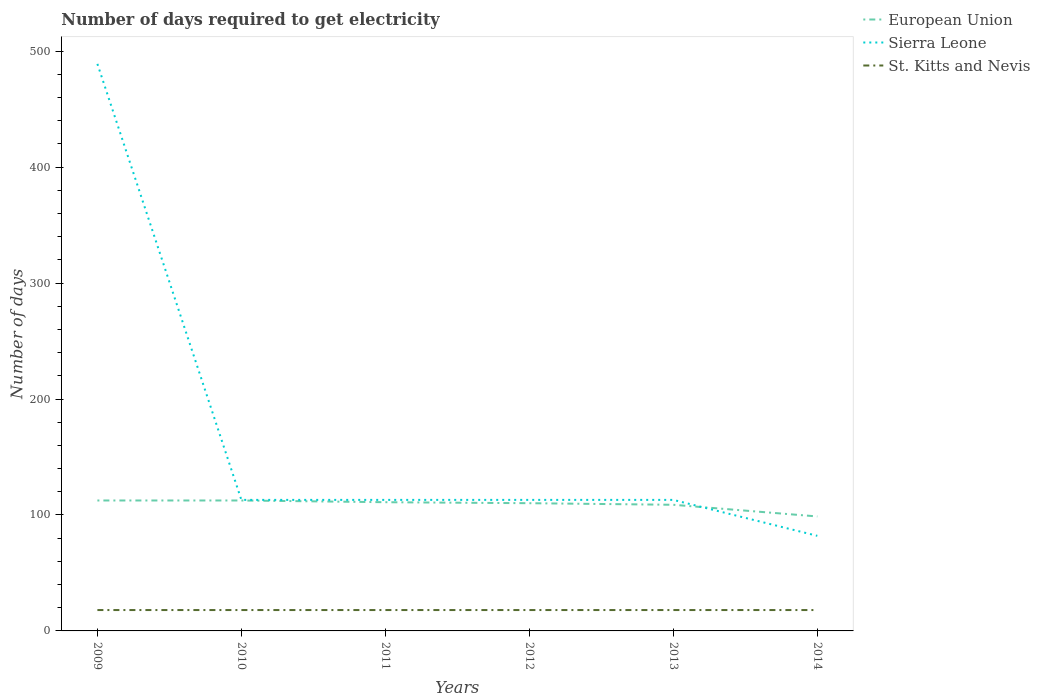How many different coloured lines are there?
Your answer should be compact. 3. Does the line corresponding to Sierra Leone intersect with the line corresponding to European Union?
Your answer should be very brief. Yes. Across all years, what is the maximum number of days required to get electricity in in Sierra Leone?
Your response must be concise. 82. In which year was the number of days required to get electricity in in Sierra Leone maximum?
Give a very brief answer. 2014. What is the total number of days required to get electricity in in St. Kitts and Nevis in the graph?
Your answer should be very brief. 0. What is the difference between the highest and the lowest number of days required to get electricity in in St. Kitts and Nevis?
Offer a terse response. 0. Is the number of days required to get electricity in in European Union strictly greater than the number of days required to get electricity in in Sierra Leone over the years?
Your answer should be compact. No. How many lines are there?
Provide a short and direct response. 3. What is the difference between two consecutive major ticks on the Y-axis?
Offer a terse response. 100. Are the values on the major ticks of Y-axis written in scientific E-notation?
Provide a short and direct response. No. Does the graph contain grids?
Offer a terse response. No. Where does the legend appear in the graph?
Offer a terse response. Top right. What is the title of the graph?
Offer a very short reply. Number of days required to get electricity. What is the label or title of the X-axis?
Your answer should be very brief. Years. What is the label or title of the Y-axis?
Provide a short and direct response. Number of days. What is the Number of days of European Union in 2009?
Ensure brevity in your answer.  112.48. What is the Number of days of Sierra Leone in 2009?
Provide a succinct answer. 489. What is the Number of days in European Union in 2010?
Provide a succinct answer. 112.48. What is the Number of days in Sierra Leone in 2010?
Make the answer very short. 113. What is the Number of days of European Union in 2011?
Provide a short and direct response. 111. What is the Number of days in Sierra Leone in 2011?
Your response must be concise. 113. What is the Number of days of St. Kitts and Nevis in 2011?
Give a very brief answer. 18. What is the Number of days in European Union in 2012?
Provide a short and direct response. 110.14. What is the Number of days of Sierra Leone in 2012?
Your answer should be compact. 113. What is the Number of days in St. Kitts and Nevis in 2012?
Your answer should be very brief. 18. What is the Number of days in European Union in 2013?
Ensure brevity in your answer.  108.79. What is the Number of days in Sierra Leone in 2013?
Provide a short and direct response. 113. What is the Number of days of St. Kitts and Nevis in 2013?
Offer a very short reply. 18. What is the Number of days in European Union in 2014?
Offer a very short reply. 98.71. What is the Number of days in St. Kitts and Nevis in 2014?
Make the answer very short. 18. Across all years, what is the maximum Number of days of European Union?
Make the answer very short. 112.48. Across all years, what is the maximum Number of days in Sierra Leone?
Provide a succinct answer. 489. Across all years, what is the maximum Number of days of St. Kitts and Nevis?
Your response must be concise. 18. Across all years, what is the minimum Number of days in European Union?
Give a very brief answer. 98.71. Across all years, what is the minimum Number of days in St. Kitts and Nevis?
Offer a very short reply. 18. What is the total Number of days in European Union in the graph?
Provide a short and direct response. 653.61. What is the total Number of days of Sierra Leone in the graph?
Keep it short and to the point. 1023. What is the total Number of days of St. Kitts and Nevis in the graph?
Offer a very short reply. 108. What is the difference between the Number of days of Sierra Leone in 2009 and that in 2010?
Offer a terse response. 376. What is the difference between the Number of days in St. Kitts and Nevis in 2009 and that in 2010?
Provide a short and direct response. 0. What is the difference between the Number of days in European Union in 2009 and that in 2011?
Offer a very short reply. 1.48. What is the difference between the Number of days in Sierra Leone in 2009 and that in 2011?
Provide a short and direct response. 376. What is the difference between the Number of days of St. Kitts and Nevis in 2009 and that in 2011?
Provide a succinct answer. 0. What is the difference between the Number of days in European Union in 2009 and that in 2012?
Give a very brief answer. 2.34. What is the difference between the Number of days in Sierra Leone in 2009 and that in 2012?
Give a very brief answer. 376. What is the difference between the Number of days in European Union in 2009 and that in 2013?
Provide a succinct answer. 3.7. What is the difference between the Number of days of Sierra Leone in 2009 and that in 2013?
Offer a terse response. 376. What is the difference between the Number of days in St. Kitts and Nevis in 2009 and that in 2013?
Offer a very short reply. 0. What is the difference between the Number of days of European Union in 2009 and that in 2014?
Ensure brevity in your answer.  13.77. What is the difference between the Number of days of Sierra Leone in 2009 and that in 2014?
Ensure brevity in your answer.  407. What is the difference between the Number of days in European Union in 2010 and that in 2011?
Offer a terse response. 1.48. What is the difference between the Number of days of European Union in 2010 and that in 2012?
Provide a succinct answer. 2.34. What is the difference between the Number of days of St. Kitts and Nevis in 2010 and that in 2012?
Provide a succinct answer. 0. What is the difference between the Number of days of European Union in 2010 and that in 2013?
Make the answer very short. 3.7. What is the difference between the Number of days in Sierra Leone in 2010 and that in 2013?
Your answer should be compact. 0. What is the difference between the Number of days of St. Kitts and Nevis in 2010 and that in 2013?
Your answer should be compact. 0. What is the difference between the Number of days in European Union in 2010 and that in 2014?
Your answer should be compact. 13.77. What is the difference between the Number of days in European Union in 2011 and that in 2012?
Ensure brevity in your answer.  0.86. What is the difference between the Number of days of Sierra Leone in 2011 and that in 2012?
Your answer should be compact. 0. What is the difference between the Number of days of European Union in 2011 and that in 2013?
Offer a terse response. 2.21. What is the difference between the Number of days of European Union in 2011 and that in 2014?
Offer a terse response. 12.29. What is the difference between the Number of days of European Union in 2012 and that in 2013?
Provide a short and direct response. 1.36. What is the difference between the Number of days of European Union in 2012 and that in 2014?
Your answer should be very brief. 11.43. What is the difference between the Number of days of St. Kitts and Nevis in 2012 and that in 2014?
Provide a succinct answer. 0. What is the difference between the Number of days in European Union in 2013 and that in 2014?
Keep it short and to the point. 10.07. What is the difference between the Number of days in Sierra Leone in 2013 and that in 2014?
Offer a very short reply. 31. What is the difference between the Number of days in St. Kitts and Nevis in 2013 and that in 2014?
Provide a short and direct response. 0. What is the difference between the Number of days in European Union in 2009 and the Number of days in Sierra Leone in 2010?
Keep it short and to the point. -0.52. What is the difference between the Number of days in European Union in 2009 and the Number of days in St. Kitts and Nevis in 2010?
Offer a terse response. 94.48. What is the difference between the Number of days in Sierra Leone in 2009 and the Number of days in St. Kitts and Nevis in 2010?
Ensure brevity in your answer.  471. What is the difference between the Number of days of European Union in 2009 and the Number of days of Sierra Leone in 2011?
Keep it short and to the point. -0.52. What is the difference between the Number of days in European Union in 2009 and the Number of days in St. Kitts and Nevis in 2011?
Offer a very short reply. 94.48. What is the difference between the Number of days of Sierra Leone in 2009 and the Number of days of St. Kitts and Nevis in 2011?
Offer a very short reply. 471. What is the difference between the Number of days of European Union in 2009 and the Number of days of Sierra Leone in 2012?
Keep it short and to the point. -0.52. What is the difference between the Number of days of European Union in 2009 and the Number of days of St. Kitts and Nevis in 2012?
Provide a succinct answer. 94.48. What is the difference between the Number of days in Sierra Leone in 2009 and the Number of days in St. Kitts and Nevis in 2012?
Offer a very short reply. 471. What is the difference between the Number of days of European Union in 2009 and the Number of days of Sierra Leone in 2013?
Provide a succinct answer. -0.52. What is the difference between the Number of days of European Union in 2009 and the Number of days of St. Kitts and Nevis in 2013?
Your answer should be compact. 94.48. What is the difference between the Number of days in Sierra Leone in 2009 and the Number of days in St. Kitts and Nevis in 2013?
Provide a succinct answer. 471. What is the difference between the Number of days in European Union in 2009 and the Number of days in Sierra Leone in 2014?
Your answer should be very brief. 30.48. What is the difference between the Number of days of European Union in 2009 and the Number of days of St. Kitts and Nevis in 2014?
Provide a succinct answer. 94.48. What is the difference between the Number of days of Sierra Leone in 2009 and the Number of days of St. Kitts and Nevis in 2014?
Provide a short and direct response. 471. What is the difference between the Number of days in European Union in 2010 and the Number of days in Sierra Leone in 2011?
Make the answer very short. -0.52. What is the difference between the Number of days in European Union in 2010 and the Number of days in St. Kitts and Nevis in 2011?
Offer a terse response. 94.48. What is the difference between the Number of days in European Union in 2010 and the Number of days in Sierra Leone in 2012?
Your answer should be compact. -0.52. What is the difference between the Number of days in European Union in 2010 and the Number of days in St. Kitts and Nevis in 2012?
Your answer should be compact. 94.48. What is the difference between the Number of days in European Union in 2010 and the Number of days in Sierra Leone in 2013?
Your answer should be compact. -0.52. What is the difference between the Number of days in European Union in 2010 and the Number of days in St. Kitts and Nevis in 2013?
Offer a very short reply. 94.48. What is the difference between the Number of days in Sierra Leone in 2010 and the Number of days in St. Kitts and Nevis in 2013?
Provide a succinct answer. 95. What is the difference between the Number of days of European Union in 2010 and the Number of days of Sierra Leone in 2014?
Provide a succinct answer. 30.48. What is the difference between the Number of days in European Union in 2010 and the Number of days in St. Kitts and Nevis in 2014?
Your response must be concise. 94.48. What is the difference between the Number of days in European Union in 2011 and the Number of days in St. Kitts and Nevis in 2012?
Ensure brevity in your answer.  93. What is the difference between the Number of days in Sierra Leone in 2011 and the Number of days in St. Kitts and Nevis in 2012?
Provide a succinct answer. 95. What is the difference between the Number of days of European Union in 2011 and the Number of days of St. Kitts and Nevis in 2013?
Provide a succinct answer. 93. What is the difference between the Number of days of Sierra Leone in 2011 and the Number of days of St. Kitts and Nevis in 2013?
Your response must be concise. 95. What is the difference between the Number of days of European Union in 2011 and the Number of days of Sierra Leone in 2014?
Offer a terse response. 29. What is the difference between the Number of days of European Union in 2011 and the Number of days of St. Kitts and Nevis in 2014?
Give a very brief answer. 93. What is the difference between the Number of days of European Union in 2012 and the Number of days of Sierra Leone in 2013?
Your answer should be compact. -2.86. What is the difference between the Number of days in European Union in 2012 and the Number of days in St. Kitts and Nevis in 2013?
Your answer should be compact. 92.14. What is the difference between the Number of days in Sierra Leone in 2012 and the Number of days in St. Kitts and Nevis in 2013?
Your answer should be compact. 95. What is the difference between the Number of days in European Union in 2012 and the Number of days in Sierra Leone in 2014?
Your response must be concise. 28.14. What is the difference between the Number of days in European Union in 2012 and the Number of days in St. Kitts and Nevis in 2014?
Make the answer very short. 92.14. What is the difference between the Number of days of European Union in 2013 and the Number of days of Sierra Leone in 2014?
Keep it short and to the point. 26.79. What is the difference between the Number of days in European Union in 2013 and the Number of days in St. Kitts and Nevis in 2014?
Your answer should be compact. 90.79. What is the difference between the Number of days of Sierra Leone in 2013 and the Number of days of St. Kitts and Nevis in 2014?
Provide a short and direct response. 95. What is the average Number of days in European Union per year?
Offer a terse response. 108.93. What is the average Number of days in Sierra Leone per year?
Make the answer very short. 170.5. What is the average Number of days in St. Kitts and Nevis per year?
Ensure brevity in your answer.  18. In the year 2009, what is the difference between the Number of days in European Union and Number of days in Sierra Leone?
Ensure brevity in your answer.  -376.52. In the year 2009, what is the difference between the Number of days in European Union and Number of days in St. Kitts and Nevis?
Your answer should be compact. 94.48. In the year 2009, what is the difference between the Number of days in Sierra Leone and Number of days in St. Kitts and Nevis?
Keep it short and to the point. 471. In the year 2010, what is the difference between the Number of days of European Union and Number of days of Sierra Leone?
Your answer should be compact. -0.52. In the year 2010, what is the difference between the Number of days in European Union and Number of days in St. Kitts and Nevis?
Offer a very short reply. 94.48. In the year 2011, what is the difference between the Number of days of European Union and Number of days of Sierra Leone?
Your response must be concise. -2. In the year 2011, what is the difference between the Number of days in European Union and Number of days in St. Kitts and Nevis?
Offer a very short reply. 93. In the year 2012, what is the difference between the Number of days of European Union and Number of days of Sierra Leone?
Your response must be concise. -2.86. In the year 2012, what is the difference between the Number of days in European Union and Number of days in St. Kitts and Nevis?
Offer a terse response. 92.14. In the year 2013, what is the difference between the Number of days in European Union and Number of days in Sierra Leone?
Your answer should be compact. -4.21. In the year 2013, what is the difference between the Number of days of European Union and Number of days of St. Kitts and Nevis?
Your answer should be very brief. 90.79. In the year 2014, what is the difference between the Number of days in European Union and Number of days in Sierra Leone?
Keep it short and to the point. 16.71. In the year 2014, what is the difference between the Number of days in European Union and Number of days in St. Kitts and Nevis?
Provide a succinct answer. 80.71. What is the ratio of the Number of days in European Union in 2009 to that in 2010?
Provide a succinct answer. 1. What is the ratio of the Number of days of Sierra Leone in 2009 to that in 2010?
Keep it short and to the point. 4.33. What is the ratio of the Number of days in European Union in 2009 to that in 2011?
Give a very brief answer. 1.01. What is the ratio of the Number of days in Sierra Leone in 2009 to that in 2011?
Your answer should be compact. 4.33. What is the ratio of the Number of days in European Union in 2009 to that in 2012?
Offer a very short reply. 1.02. What is the ratio of the Number of days in Sierra Leone in 2009 to that in 2012?
Keep it short and to the point. 4.33. What is the ratio of the Number of days of St. Kitts and Nevis in 2009 to that in 2012?
Your answer should be very brief. 1. What is the ratio of the Number of days in European Union in 2009 to that in 2013?
Offer a terse response. 1.03. What is the ratio of the Number of days of Sierra Leone in 2009 to that in 2013?
Give a very brief answer. 4.33. What is the ratio of the Number of days of St. Kitts and Nevis in 2009 to that in 2013?
Your answer should be very brief. 1. What is the ratio of the Number of days in European Union in 2009 to that in 2014?
Your answer should be very brief. 1.14. What is the ratio of the Number of days in Sierra Leone in 2009 to that in 2014?
Offer a terse response. 5.96. What is the ratio of the Number of days of St. Kitts and Nevis in 2009 to that in 2014?
Ensure brevity in your answer.  1. What is the ratio of the Number of days in European Union in 2010 to that in 2011?
Offer a very short reply. 1.01. What is the ratio of the Number of days in St. Kitts and Nevis in 2010 to that in 2011?
Offer a terse response. 1. What is the ratio of the Number of days in European Union in 2010 to that in 2012?
Your answer should be very brief. 1.02. What is the ratio of the Number of days in St. Kitts and Nevis in 2010 to that in 2012?
Your response must be concise. 1. What is the ratio of the Number of days in European Union in 2010 to that in 2013?
Your answer should be very brief. 1.03. What is the ratio of the Number of days of Sierra Leone in 2010 to that in 2013?
Make the answer very short. 1. What is the ratio of the Number of days in St. Kitts and Nevis in 2010 to that in 2013?
Ensure brevity in your answer.  1. What is the ratio of the Number of days of European Union in 2010 to that in 2014?
Ensure brevity in your answer.  1.14. What is the ratio of the Number of days in Sierra Leone in 2010 to that in 2014?
Give a very brief answer. 1.38. What is the ratio of the Number of days of European Union in 2011 to that in 2012?
Provide a short and direct response. 1.01. What is the ratio of the Number of days in St. Kitts and Nevis in 2011 to that in 2012?
Your answer should be compact. 1. What is the ratio of the Number of days of European Union in 2011 to that in 2013?
Keep it short and to the point. 1.02. What is the ratio of the Number of days in St. Kitts and Nevis in 2011 to that in 2013?
Offer a very short reply. 1. What is the ratio of the Number of days of European Union in 2011 to that in 2014?
Provide a succinct answer. 1.12. What is the ratio of the Number of days in Sierra Leone in 2011 to that in 2014?
Your answer should be very brief. 1.38. What is the ratio of the Number of days of St. Kitts and Nevis in 2011 to that in 2014?
Give a very brief answer. 1. What is the ratio of the Number of days in European Union in 2012 to that in 2013?
Make the answer very short. 1.01. What is the ratio of the Number of days in European Union in 2012 to that in 2014?
Ensure brevity in your answer.  1.12. What is the ratio of the Number of days in Sierra Leone in 2012 to that in 2014?
Your response must be concise. 1.38. What is the ratio of the Number of days in St. Kitts and Nevis in 2012 to that in 2014?
Offer a terse response. 1. What is the ratio of the Number of days in European Union in 2013 to that in 2014?
Make the answer very short. 1.1. What is the ratio of the Number of days of Sierra Leone in 2013 to that in 2014?
Your answer should be very brief. 1.38. What is the difference between the highest and the second highest Number of days in Sierra Leone?
Provide a short and direct response. 376. What is the difference between the highest and the lowest Number of days in European Union?
Your answer should be compact. 13.77. What is the difference between the highest and the lowest Number of days of Sierra Leone?
Your answer should be compact. 407. What is the difference between the highest and the lowest Number of days in St. Kitts and Nevis?
Your answer should be very brief. 0. 